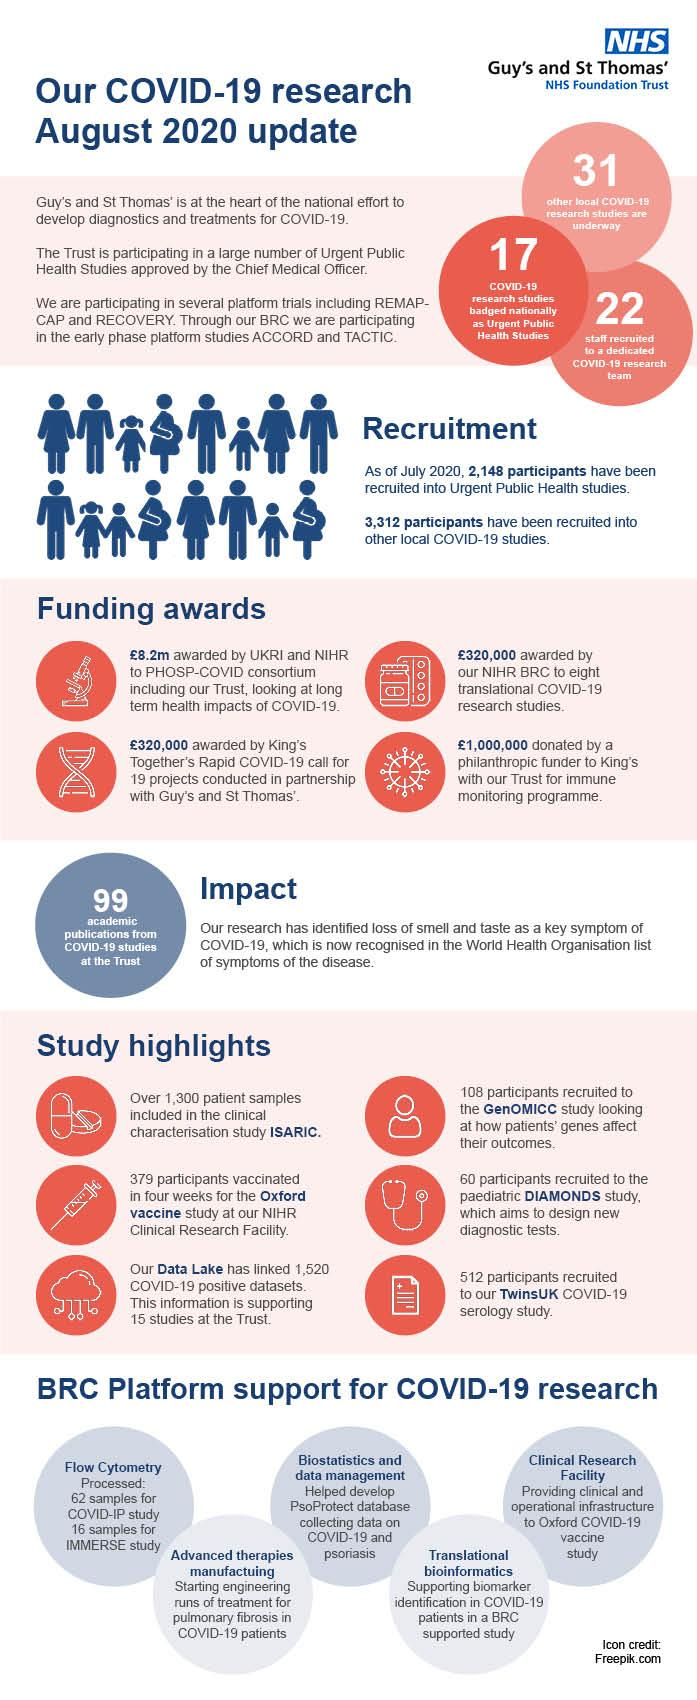Highlight a few significant elements in this photo. The Oxford COVID-19 vaccine study was supported by a clinical research facility. The use of biostatistics and data management techniques was instrumental in the collection of data on COVID-19 and psoriasis. The National Institute for Health Research Biomedical Research Centre and King's have been awarded a total of 640000... The Trust has published 99 publications related to COVID-19 studies. Thirty-one other local COVID-19 studies are currently underway. 